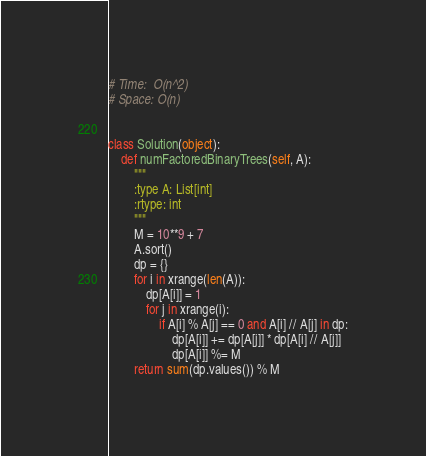<code> <loc_0><loc_0><loc_500><loc_500><_Python_># Time:  O(n^2)
# Space: O(n)


class Solution(object):
    def numFactoredBinaryTrees(self, A):
        """
        :type A: List[int]
        :rtype: int
        """
        M = 10**9 + 7
        A.sort()
        dp = {}
        for i in xrange(len(A)):
            dp[A[i]] = 1
            for j in xrange(i):
                if A[i] % A[j] == 0 and A[i] // A[j] in dp:
                    dp[A[i]] += dp[A[j]] * dp[A[i] // A[j]]
                    dp[A[i]] %= M
        return sum(dp.values()) % M

</code> 